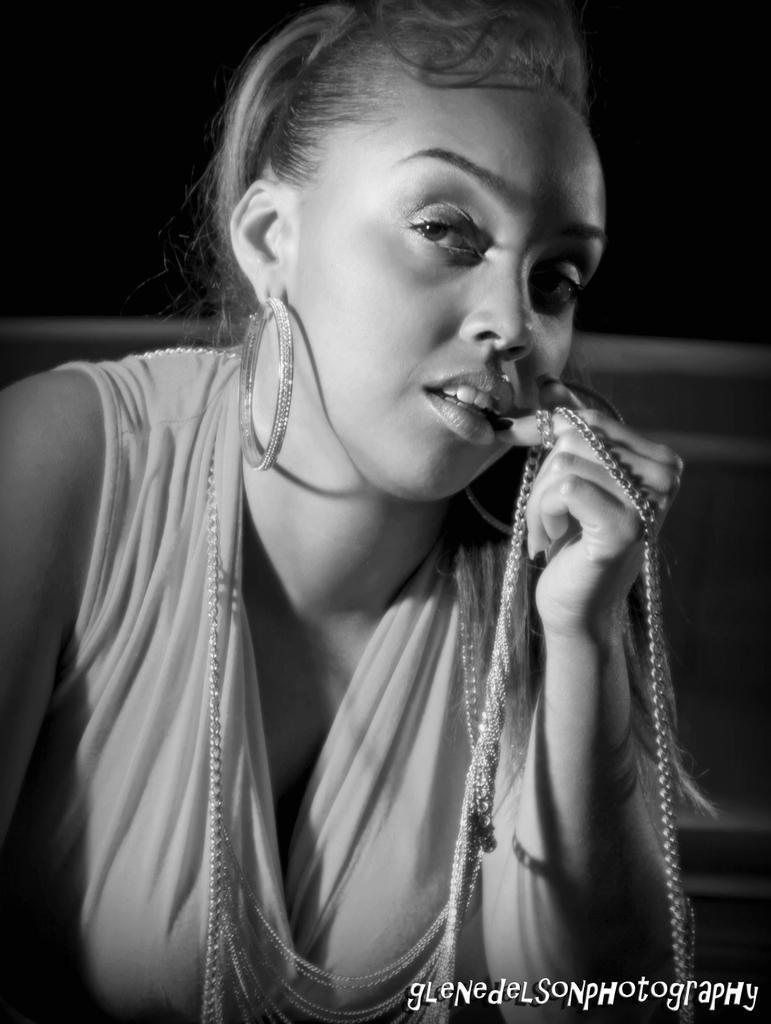Describe this image in one or two sentences. It is a black and white image, there is a woman in the foreground and she wrapped a chain around her finger. 